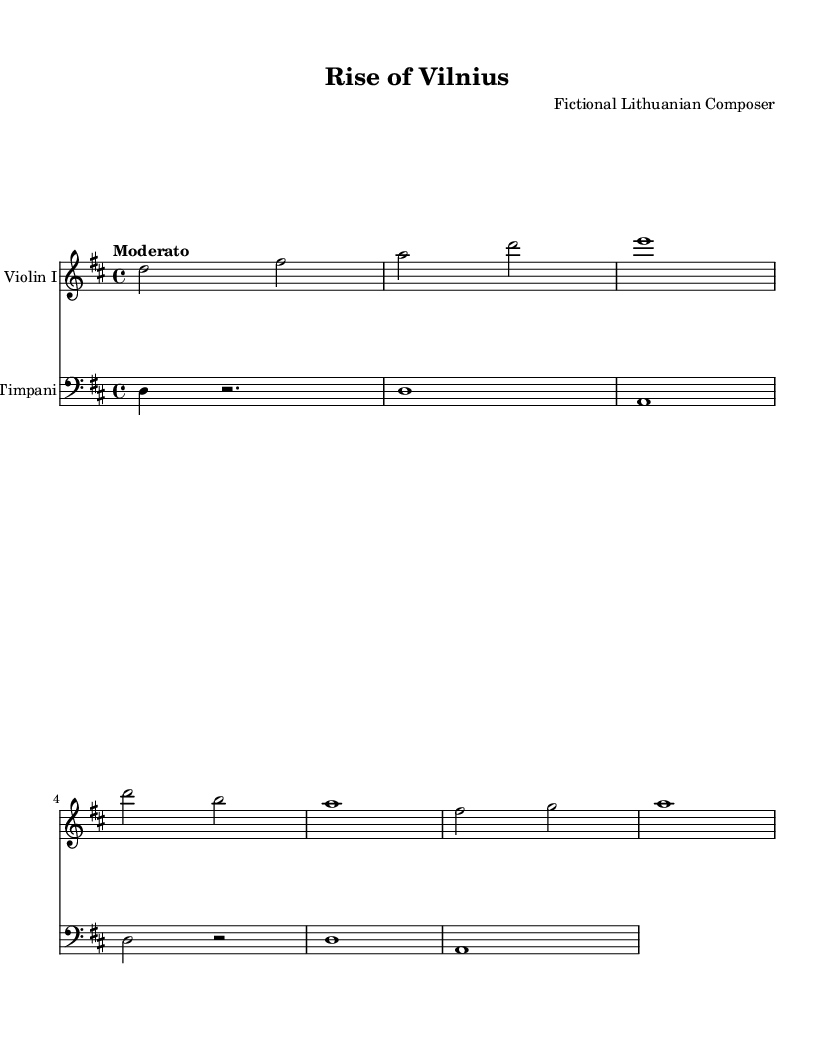What is the key signature of this music? The key signature is D major, which has two sharps (F# and C#). We can derive this from the global declaration in the sheet music that states "\key d \major".
Answer: D major What is the time signature of this music? The time signature is 4/4, as indicated in the global settings with "\time 4/4". This means there are four beats per measure, and the quarter note gets the beat.
Answer: 4/4 What is the tempo marking of this piece? The tempo marking is Moderato, as specified in the global section. It indicates a moderate speed for the performance of the piece.
Answer: Moderato Which instrument has the highest part in this score? The Violin I part has the highest pitch in this score, as it is in the treble clef and contains notes higher than the bass clef used for the Timpani.
Answer: Violin I What note value is held for the last measure in the Violin I part? The last measure in the Violin I part contains a whole note (e1), which is a note that lasts for four beats in common time. We determine this by looking at the rhythmic values written in that specific measure.
Answer: whole note How many measures does the Violin I part consist of in this excerpt? The Violin I part consists of six measures as we count each set of bar lines in the staff, which indicate the end of each measure.
Answer: 6 measures 